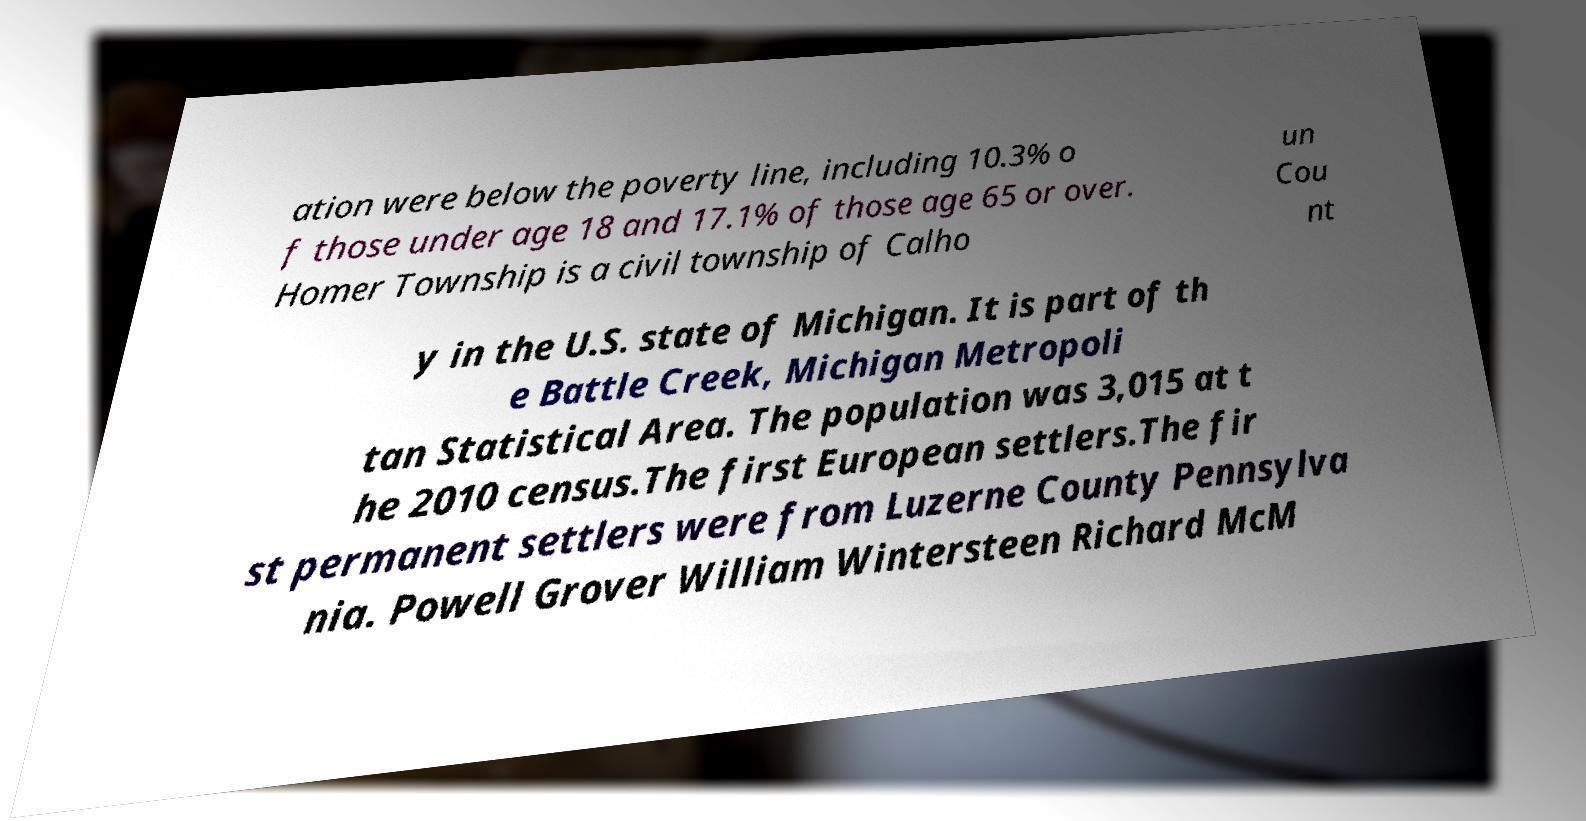There's text embedded in this image that I need extracted. Can you transcribe it verbatim? ation were below the poverty line, including 10.3% o f those under age 18 and 17.1% of those age 65 or over. Homer Township is a civil township of Calho un Cou nt y in the U.S. state of Michigan. It is part of th e Battle Creek, Michigan Metropoli tan Statistical Area. The population was 3,015 at t he 2010 census.The first European settlers.The fir st permanent settlers were from Luzerne County Pennsylva nia. Powell Grover William Wintersteen Richard McM 